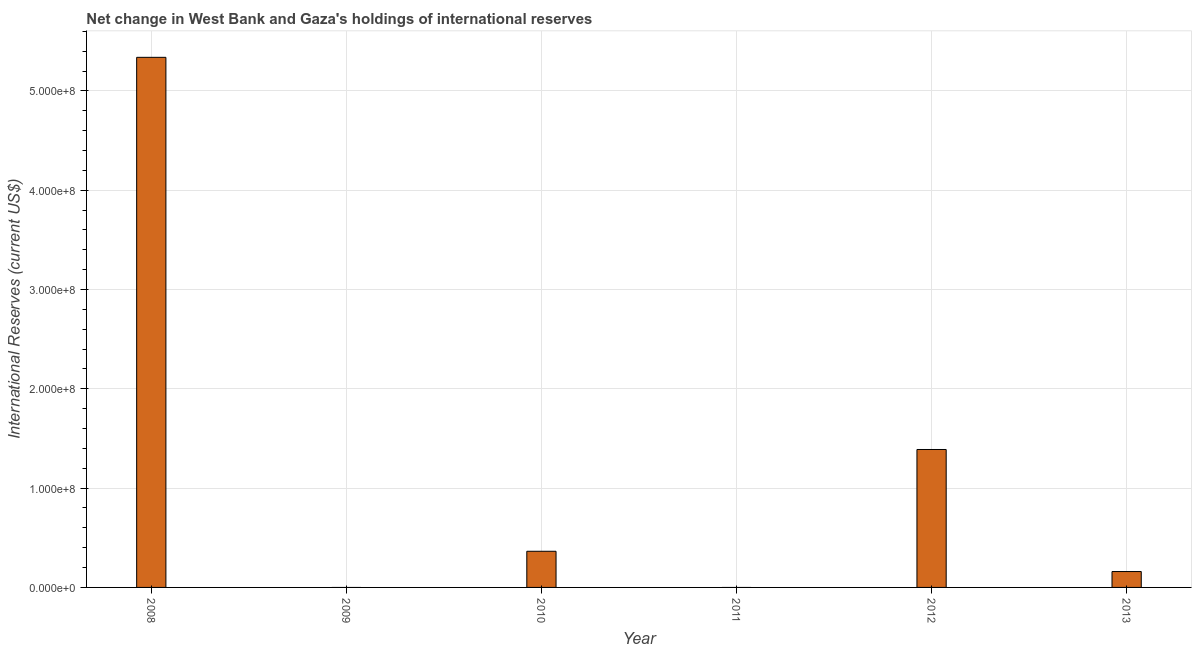Does the graph contain any zero values?
Offer a very short reply. Yes. Does the graph contain grids?
Keep it short and to the point. Yes. What is the title of the graph?
Make the answer very short. Net change in West Bank and Gaza's holdings of international reserves. What is the label or title of the Y-axis?
Provide a short and direct response. International Reserves (current US$). What is the reserves and related items in 2011?
Give a very brief answer. 0. Across all years, what is the maximum reserves and related items?
Your response must be concise. 5.34e+08. What is the sum of the reserves and related items?
Give a very brief answer. 7.25e+08. What is the difference between the reserves and related items in 2008 and 2012?
Provide a short and direct response. 3.95e+08. What is the average reserves and related items per year?
Give a very brief answer. 1.21e+08. What is the median reserves and related items?
Make the answer very short. 2.62e+07. In how many years, is the reserves and related items greater than 480000000 US$?
Your answer should be very brief. 1. What is the ratio of the reserves and related items in 2010 to that in 2012?
Your response must be concise. 0.26. Is the reserves and related items in 2008 less than that in 2012?
Your response must be concise. No. What is the difference between the highest and the second highest reserves and related items?
Your answer should be very brief. 3.95e+08. What is the difference between the highest and the lowest reserves and related items?
Provide a short and direct response. 5.34e+08. How many bars are there?
Provide a succinct answer. 4. What is the difference between two consecutive major ticks on the Y-axis?
Make the answer very short. 1.00e+08. Are the values on the major ticks of Y-axis written in scientific E-notation?
Your response must be concise. Yes. What is the International Reserves (current US$) in 2008?
Your response must be concise. 5.34e+08. What is the International Reserves (current US$) of 2009?
Your response must be concise. 0. What is the International Reserves (current US$) in 2010?
Offer a terse response. 3.64e+07. What is the International Reserves (current US$) in 2012?
Your response must be concise. 1.39e+08. What is the International Reserves (current US$) in 2013?
Give a very brief answer. 1.60e+07. What is the difference between the International Reserves (current US$) in 2008 and 2010?
Provide a short and direct response. 4.97e+08. What is the difference between the International Reserves (current US$) in 2008 and 2012?
Provide a succinct answer. 3.95e+08. What is the difference between the International Reserves (current US$) in 2008 and 2013?
Keep it short and to the point. 5.18e+08. What is the difference between the International Reserves (current US$) in 2010 and 2012?
Offer a terse response. -1.02e+08. What is the difference between the International Reserves (current US$) in 2010 and 2013?
Give a very brief answer. 2.04e+07. What is the difference between the International Reserves (current US$) in 2012 and 2013?
Your answer should be very brief. 1.23e+08. What is the ratio of the International Reserves (current US$) in 2008 to that in 2010?
Provide a short and direct response. 14.66. What is the ratio of the International Reserves (current US$) in 2008 to that in 2012?
Offer a very short reply. 3.84. What is the ratio of the International Reserves (current US$) in 2008 to that in 2013?
Offer a very short reply. 33.38. What is the ratio of the International Reserves (current US$) in 2010 to that in 2012?
Offer a very short reply. 0.26. What is the ratio of the International Reserves (current US$) in 2010 to that in 2013?
Offer a very short reply. 2.28. What is the ratio of the International Reserves (current US$) in 2012 to that in 2013?
Give a very brief answer. 8.68. 